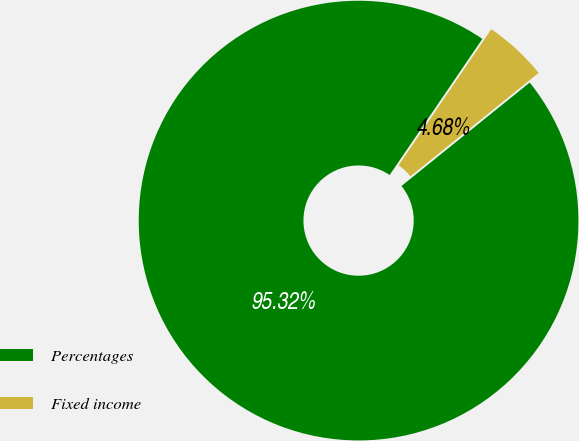<chart> <loc_0><loc_0><loc_500><loc_500><pie_chart><fcel>Percentages<fcel>Fixed income<nl><fcel>95.32%<fcel>4.68%<nl></chart> 